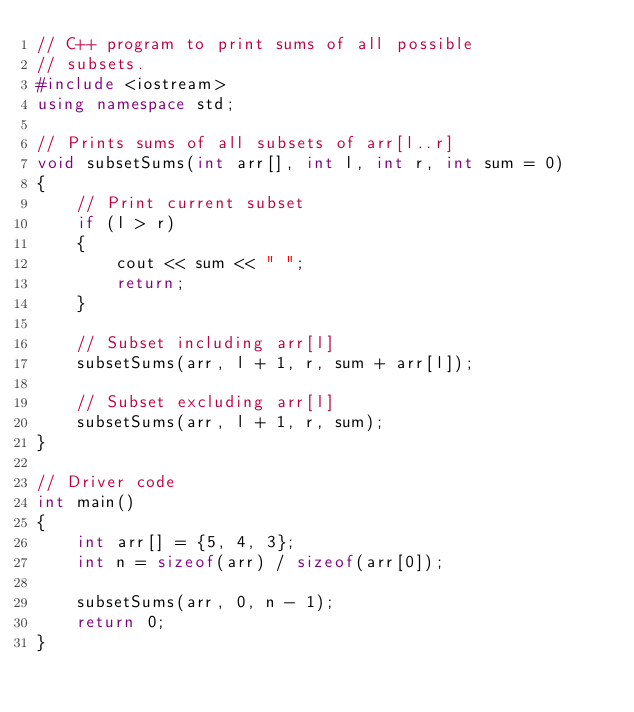<code> <loc_0><loc_0><loc_500><loc_500><_C++_>// C++ program to print sums of all possible
// subsets.
#include <iostream>
using namespace std;

// Prints sums of all subsets of arr[l..r]
void subsetSums(int arr[], int l, int r, int sum = 0)
{
    // Print current subset
    if (l > r)
    {
        cout << sum << " ";
        return;
    }

    // Subset including arr[l]
    subsetSums(arr, l + 1, r, sum + arr[l]);

    // Subset excluding arr[l]
    subsetSums(arr, l + 1, r, sum);
}

// Driver code
int main()
{
    int arr[] = {5, 4, 3};
    int n = sizeof(arr) / sizeof(arr[0]);

    subsetSums(arr, 0, n - 1);
    return 0;
}</code> 